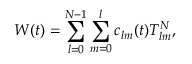<formula> <loc_0><loc_0><loc_500><loc_500>W ( t ) = \sum _ { l = 0 } ^ { N - 1 } \sum _ { m = 0 } ^ { l } c _ { l m } ( t ) T _ { l m } ^ { N } ,</formula> 